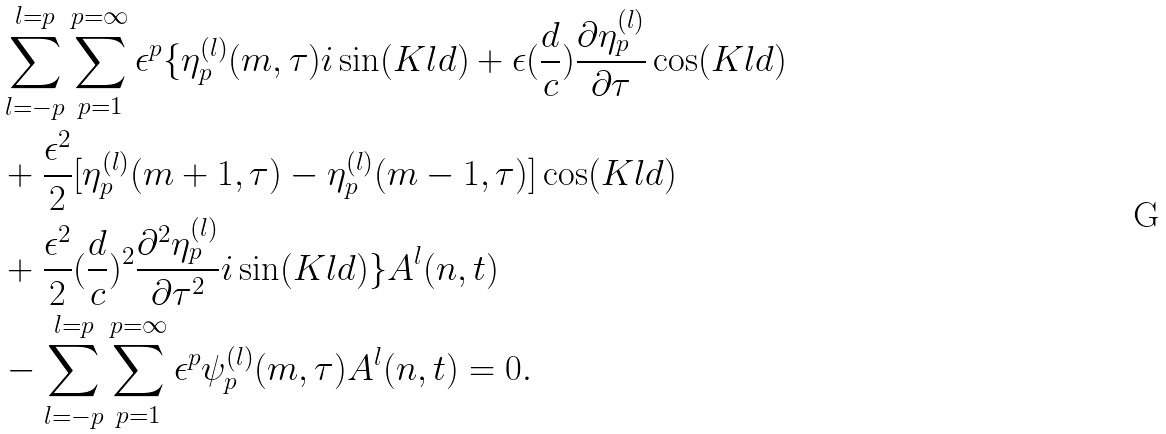<formula> <loc_0><loc_0><loc_500><loc_500>& \sum ^ { l = p } _ { l = - p } \sum ^ { p = \infty } _ { p = 1 } \epsilon ^ { p } \{ \eta ^ { ( l ) } _ { p } ( m , \tau ) i \sin ( K l d ) + \epsilon ( \frac { d } { c } ) \frac { \partial \eta ^ { ( l ) } _ { p } } { \partial \tau } \cos ( K l d ) \\ & + \frac { \epsilon ^ { 2 } } { 2 } [ \eta ^ { ( l ) } _ { p } ( m + 1 , \tau ) - \eta ^ { ( l ) } _ { p } ( m - 1 , \tau ) ] \cos ( K l d ) \\ & + \frac { \epsilon ^ { 2 } } { 2 } ( \frac { d } { c } ) ^ { 2 } \frac { \partial ^ { 2 } \eta ^ { ( l ) } _ { p } } { \partial \tau ^ { 2 } } i \sin ( K l d ) \} A ^ { l } ( n , t ) \\ & - \sum ^ { l = p } _ { l = - p } \sum ^ { p = \infty } _ { p = 1 } \epsilon ^ { p } \psi ^ { ( l ) } _ { p } ( m , \tau ) A ^ { l } ( n , t ) = 0 .</formula> 